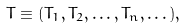<formula> <loc_0><loc_0><loc_500><loc_500>T \equiv ( T _ { 1 } , T _ { 2 } , \dots , T _ { n } , \dots ) ,</formula> 